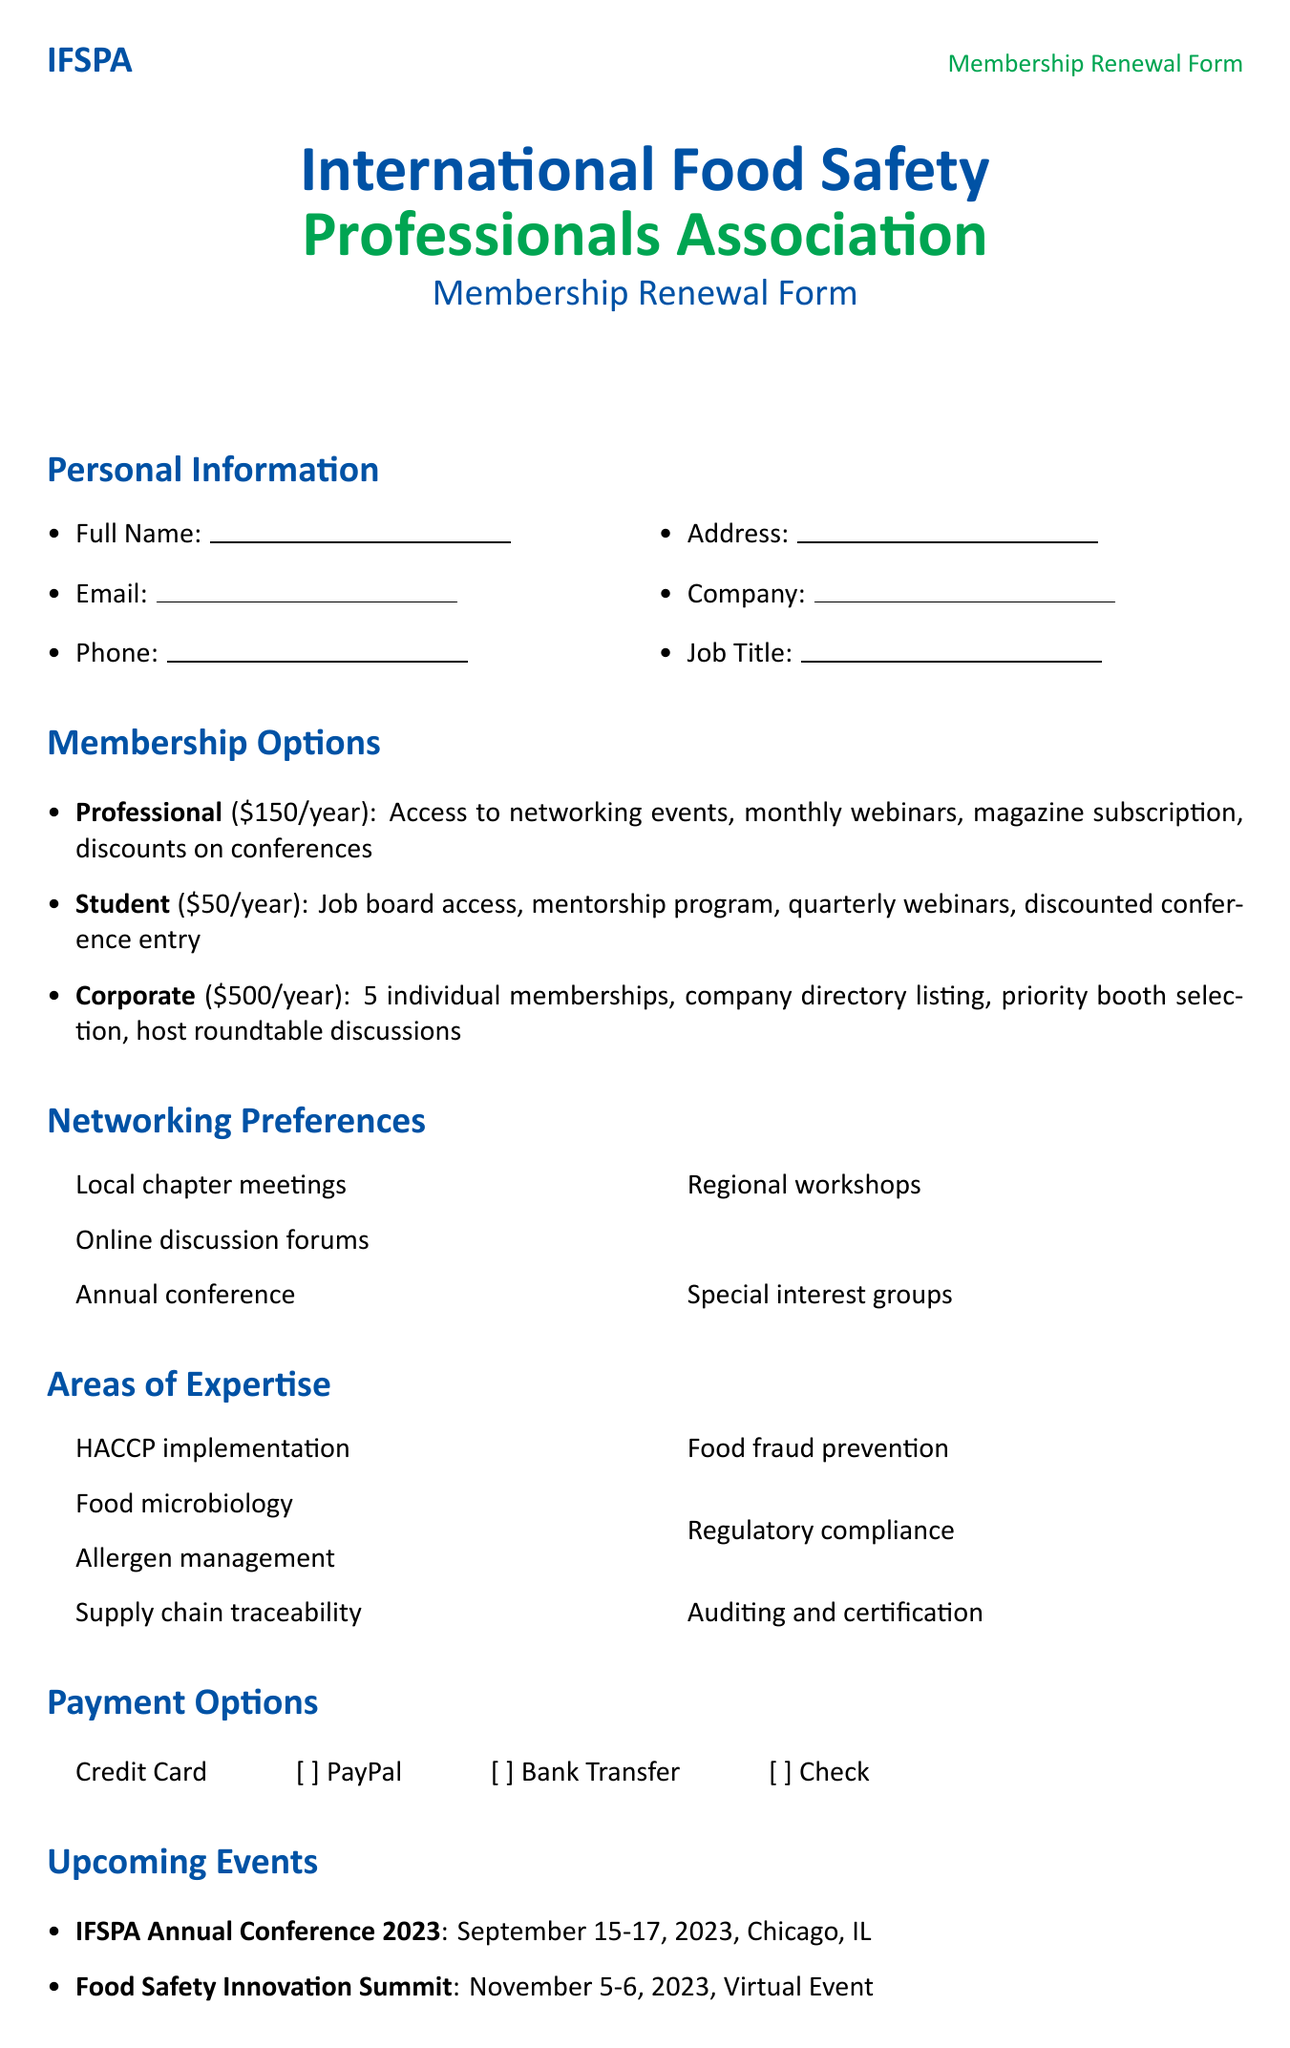What is the name of the association? The name of the association is clearly stated at the beginning of the document.
Answer: International Food Safety Professionals Association (IFSPA) What is the annual fee for a Professional membership? The annual fee for a Professional membership is listed under the membership options section.
Answer: 150 What is one benefit of the Student membership? A benefit of the Student membership is mentioned in the list of benefits provided.
Answer: Mentorship program When is the IFSPA Annual Conference 2023 scheduled? The date of the IFSPA Annual Conference is provided in the upcoming events section.
Answer: September 15-17, 2023 How many individual memberships does a Corporate membership include? This information is provided in the membership options section.
Answer: 5 What discount is offered for renewing for 2 years? The discount for renewing for 2 years is stated under the special offers section.
Answer: 10% off Which payment option is NOT listed in the document? This question requires recalling the payment options mentioned.
Answer: None (all options are listed) What is one area of expertise mentioned in the document? An area of expertise can be found in the listed areas of expertise section.
Answer: Food microbiology Which committee can members volunteer for? The document lists several committees for volunteer opportunities.
Answer: Education and Training Committee 